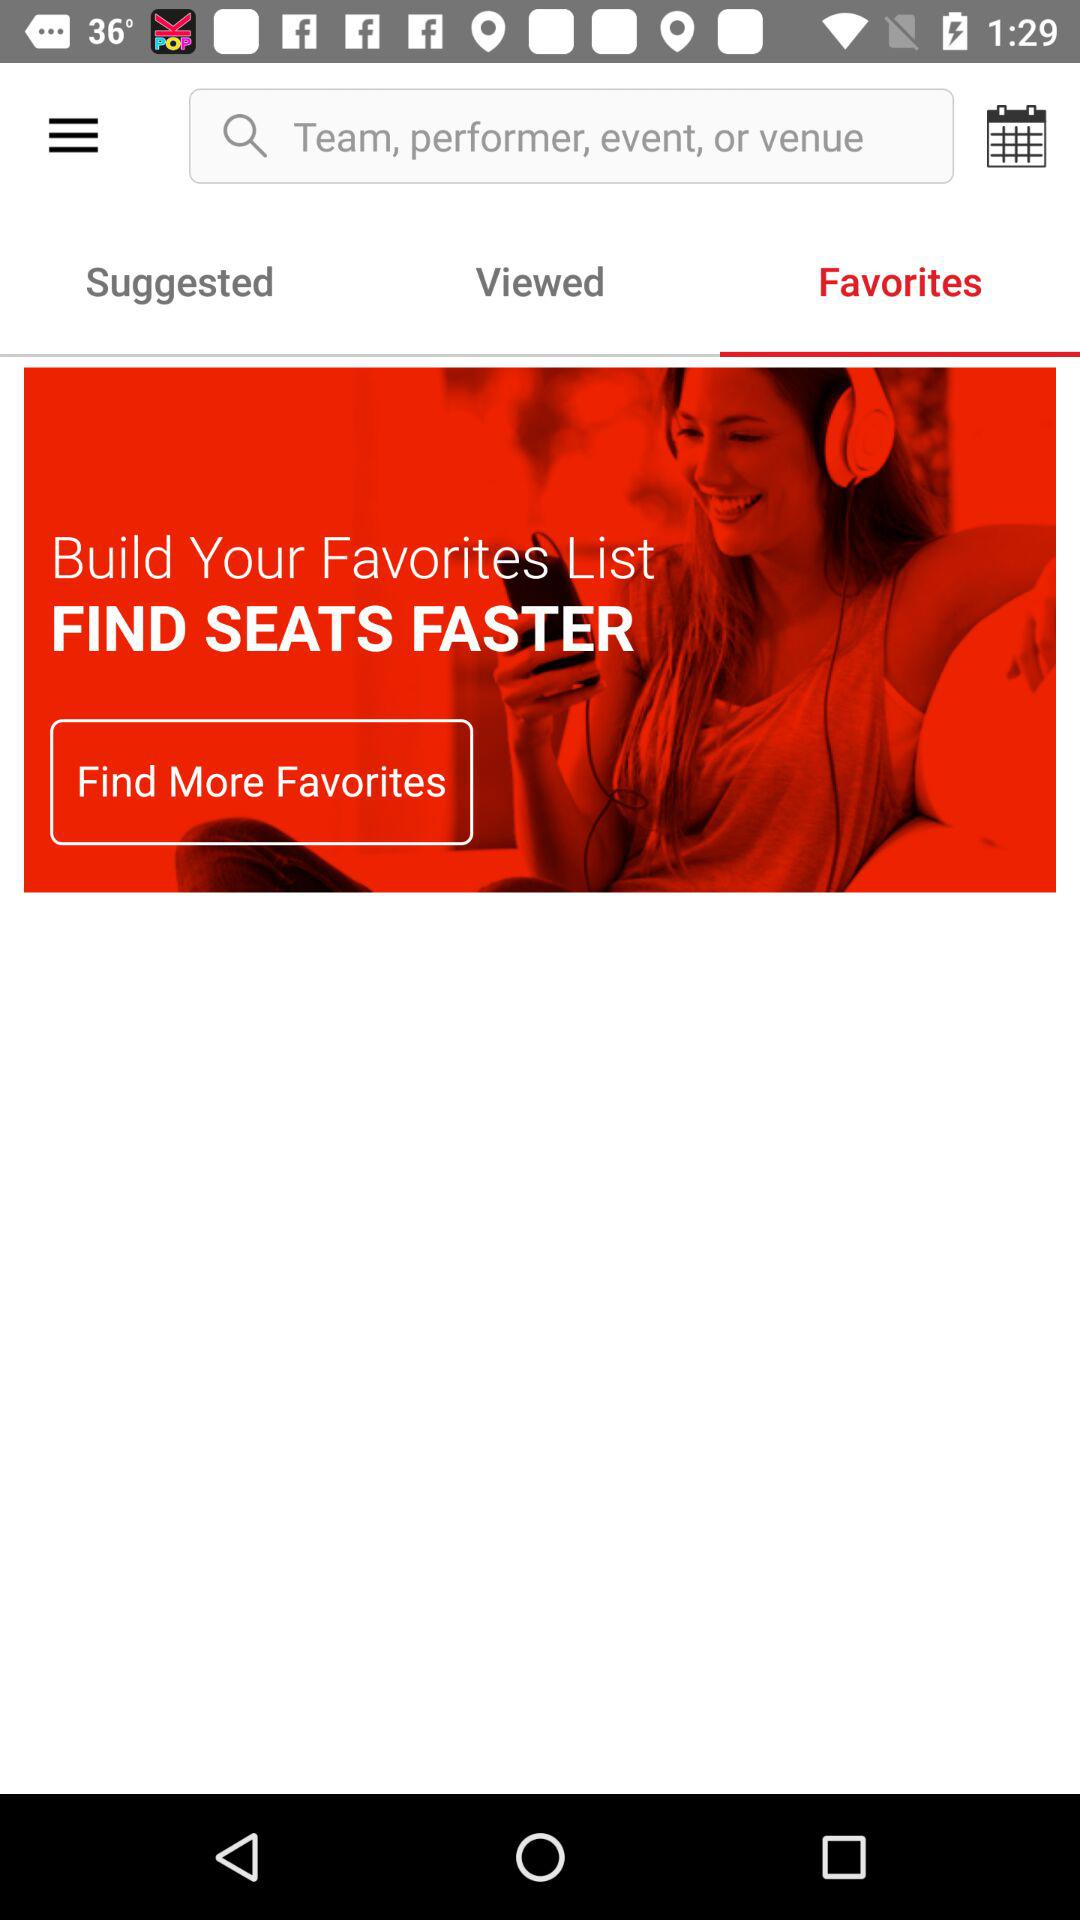Which tab is open? The open tab is "Favorites". 